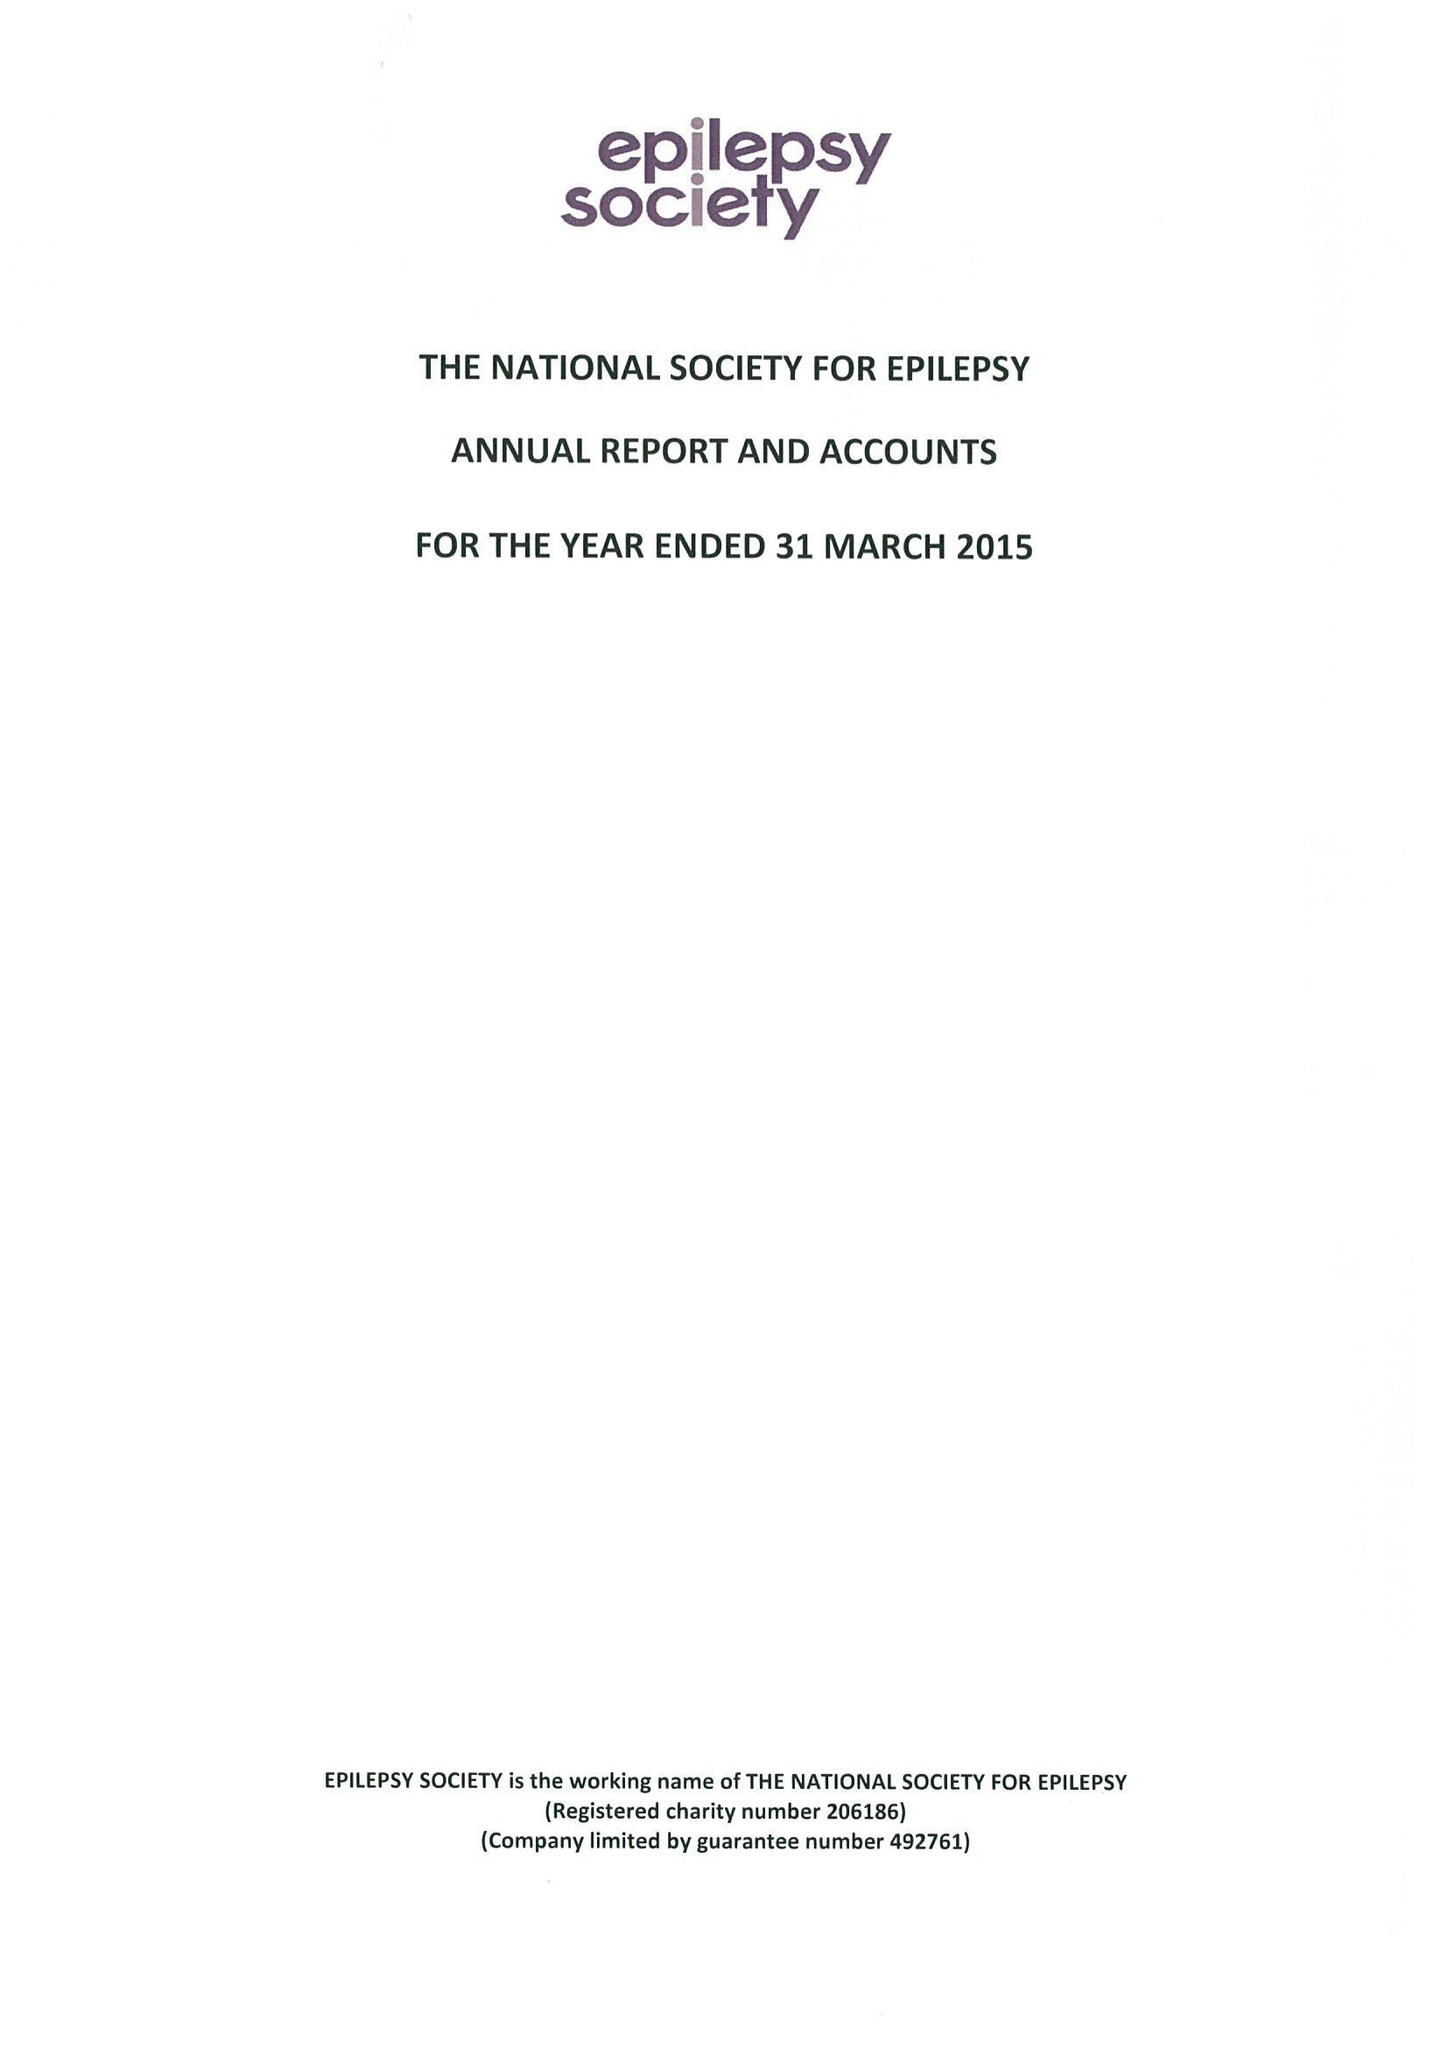What is the value for the income_annually_in_british_pounds?
Answer the question using a single word or phrase. 16515000.00 